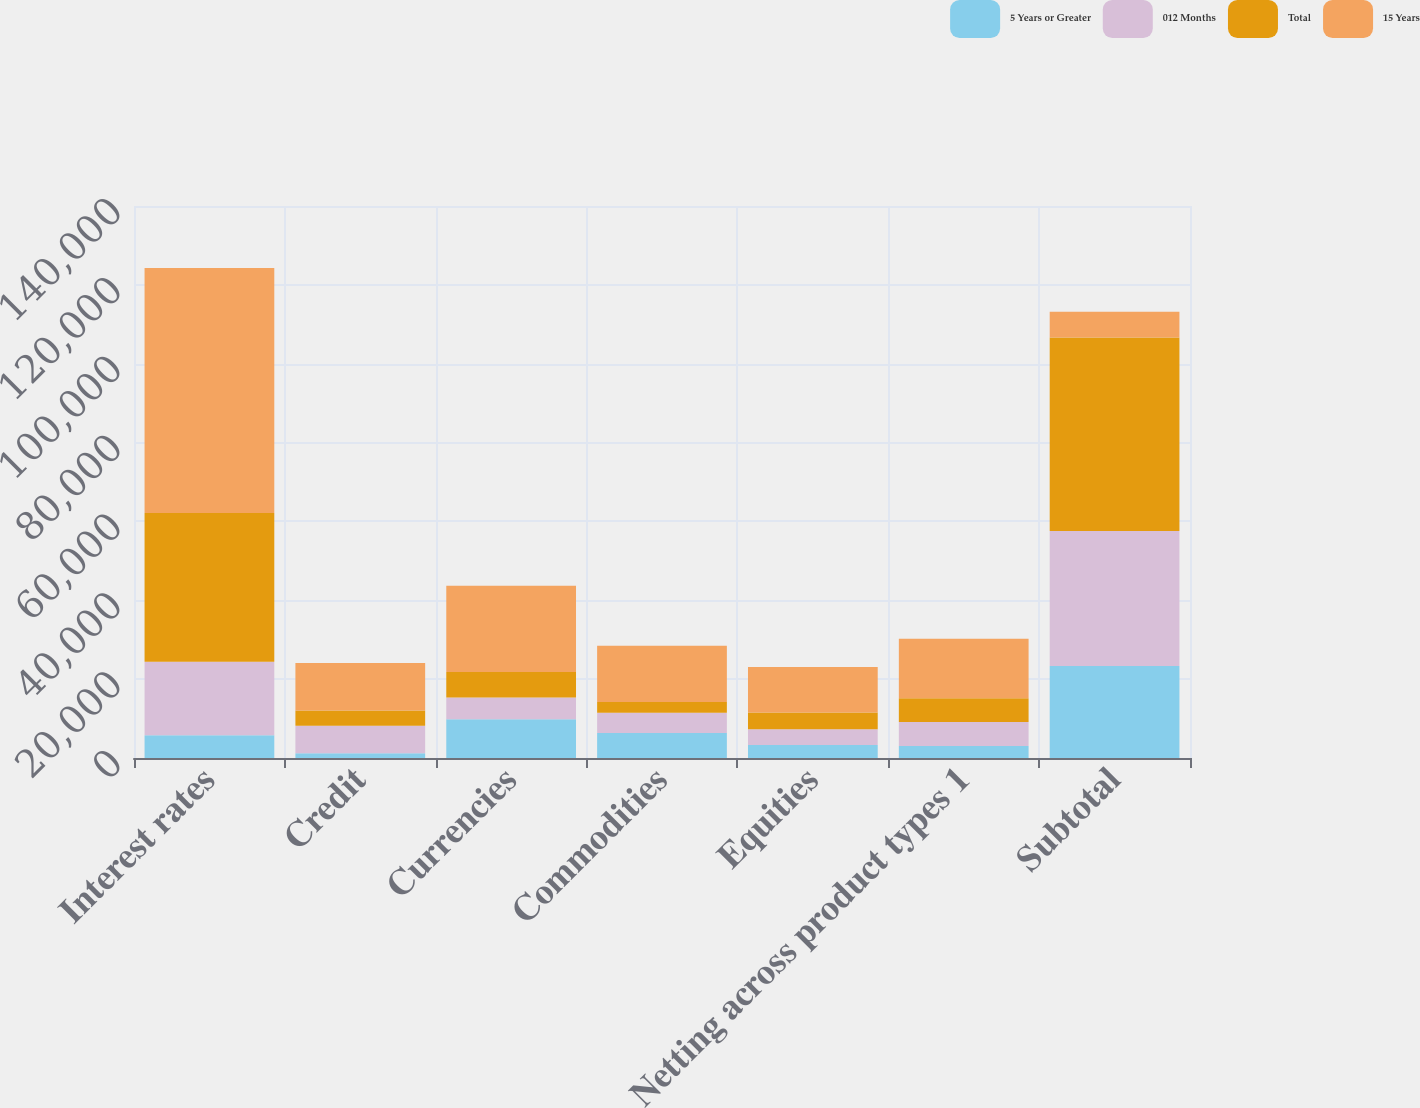Convert chart to OTSL. <chart><loc_0><loc_0><loc_500><loc_500><stacked_bar_chart><ecel><fcel>Interest rates<fcel>Credit<fcel>Currencies<fcel>Commodities<fcel>Equities<fcel>Netting across product types 1<fcel>Subtotal<nl><fcel>5 Years or Greater<fcel>5787<fcel>1200<fcel>9826<fcel>6322<fcel>3290<fcel>3071<fcel>23354<nl><fcel>012 Months<fcel>18607<fcel>6957<fcel>5514<fcel>5174<fcel>4018<fcel>6033<fcel>34237<nl><fcel>Total<fcel>37739<fcel>3894<fcel>6502<fcel>2727<fcel>4246<fcel>6027<fcel>49081<nl><fcel>15 Years<fcel>62133<fcel>12051<fcel>21842<fcel>14223<fcel>11554<fcel>15131<fcel>6502<nl></chart> 